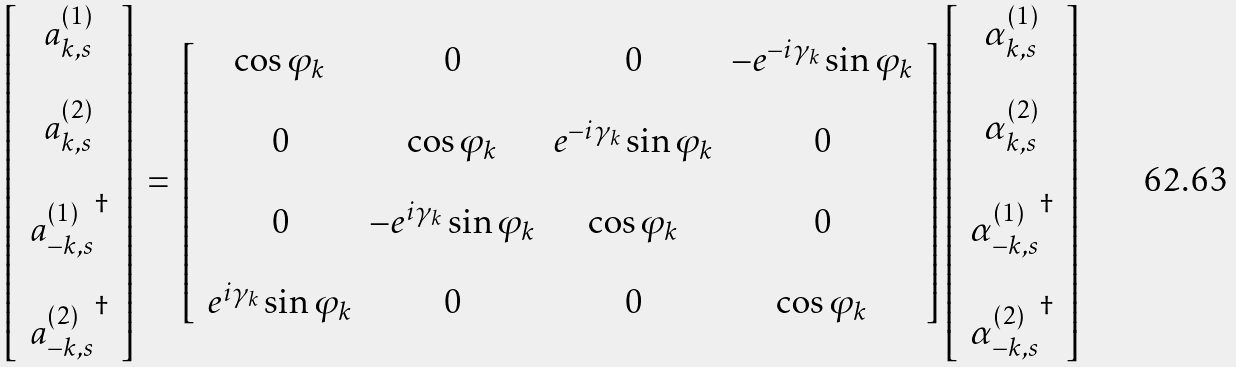<formula> <loc_0><loc_0><loc_500><loc_500>\left [ \, \begin{array} { c } a _ { { k } , s } ^ { ( 1 ) } \\ \\ a _ { { k } , s } ^ { ( 2 ) } \\ \\ { a _ { - { k } , s } ^ { ( 1 ) } } ^ { \dag } \\ \\ { a _ { - { k } , s } ^ { ( 2 ) } } ^ { \dag } \end{array} \, \right ] \, = \, \left [ \, \begin{array} { c c c c } \cos \varphi _ { k } & 0 & 0 & - e ^ { - i \gamma _ { k } } \sin \varphi _ { k } \\ & & & \\ 0 & \cos \varphi _ { k } & e ^ { - i \gamma _ { k } } \sin \varphi _ { k } & 0 \\ & & & \\ 0 & - e ^ { i \gamma _ { k } } \sin \varphi _ { k } & \cos \varphi _ { k } & 0 \\ & & & \\ e ^ { i \gamma _ { k } } \sin \varphi _ { k } & 0 & 0 & \cos \varphi _ { k } \end{array} \, \right ] \left [ \, \begin{array} { c } \alpha _ { { k } , s } ^ { ( 1 ) } \\ \\ \alpha _ { { k } , s } ^ { ( 2 ) } \\ \\ { \alpha _ { - { k } , s } ^ { ( 1 ) } } ^ { \dag } \\ \\ { \alpha _ { - { k } , s } ^ { ( 2 ) } } ^ { \dag } \end{array} \, \right ]</formula> 